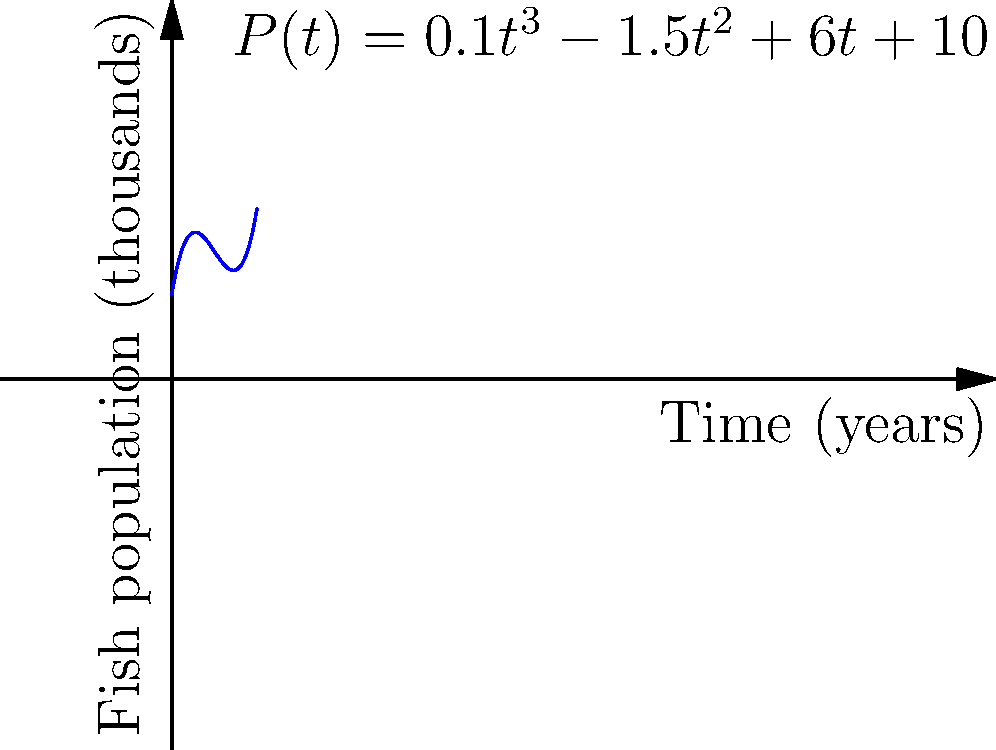As a fisherman using modern technology, you're monitoring the fish population in a local lake. The population growth over time can be modeled by the cubic function $P(t) = 0.1t^3 - 1.5t^2 + 6t + 10$, where $P(t)$ represents the fish population in thousands and $t$ is the time in years. At what time does the fish population reach its minimum value within the first 10 years? To find the minimum value of the fish population, we need to follow these steps:

1) The minimum point occurs where the derivative of the function is zero. Let's find the derivative:

   $P'(t) = 0.3t^2 - 3t + 6$

2) Set the derivative equal to zero and solve for t:

   $0.3t^2 - 3t + 6 = 0$

3) This is a quadratic equation. We can solve it using the quadratic formula:

   $t = \frac{-b \pm \sqrt{b^2 - 4ac}}{2a}$

   Where $a = 0.3$, $b = -3$, and $c = 6$

4) Plugging in these values:

   $t = \frac{3 \pm \sqrt{9 - 7.2}}{0.6} = \frac{3 \pm \sqrt{1.8}}{0.6}$

5) Simplifying:

   $t = \frac{3 \pm 1.34}{0.6} = 5$ or $2.77$

6) Since we're only concerned with the first 10 years, both these values are relevant. The smaller value, 2.77 years, corresponds to the minimum point.

Therefore, the fish population reaches its minimum value after approximately 2.77 years.
Answer: 2.77 years 